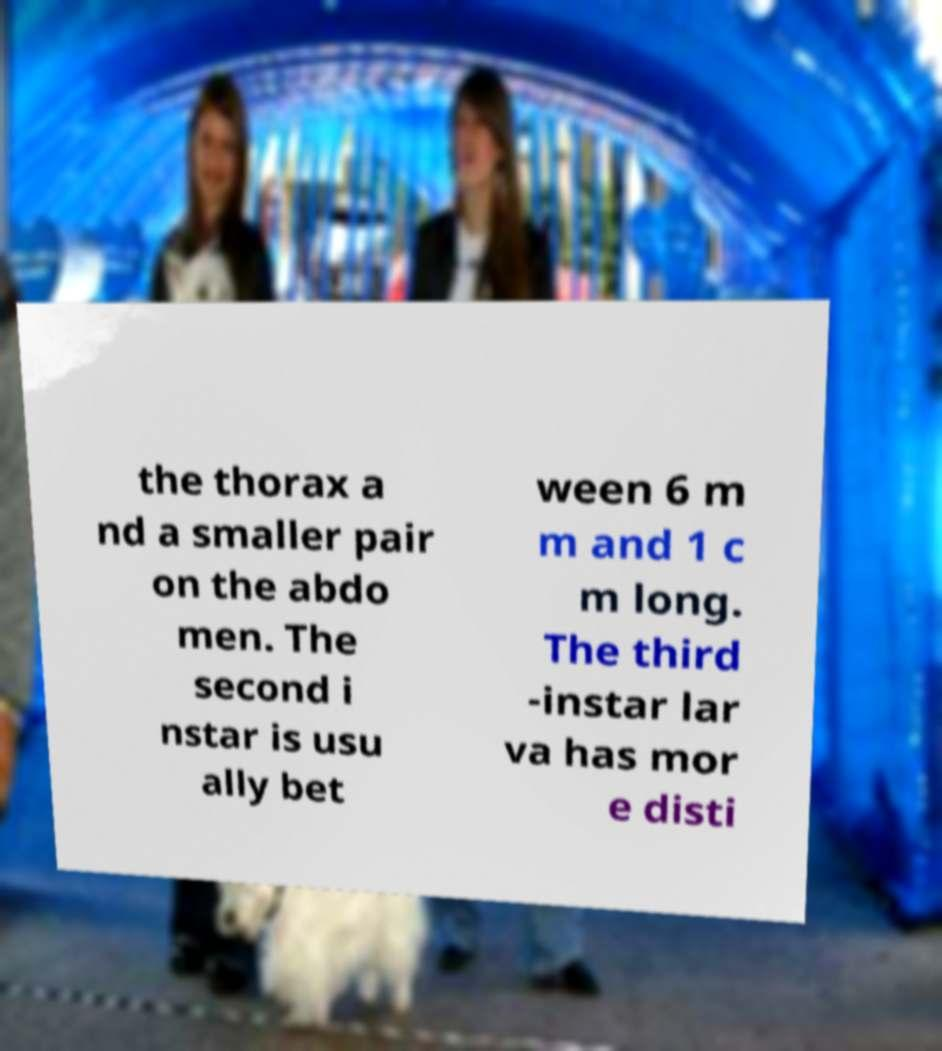Could you assist in decoding the text presented in this image and type it out clearly? the thorax a nd a smaller pair on the abdo men. The second i nstar is usu ally bet ween 6 m m and 1 c m long. The third -instar lar va has mor e disti 